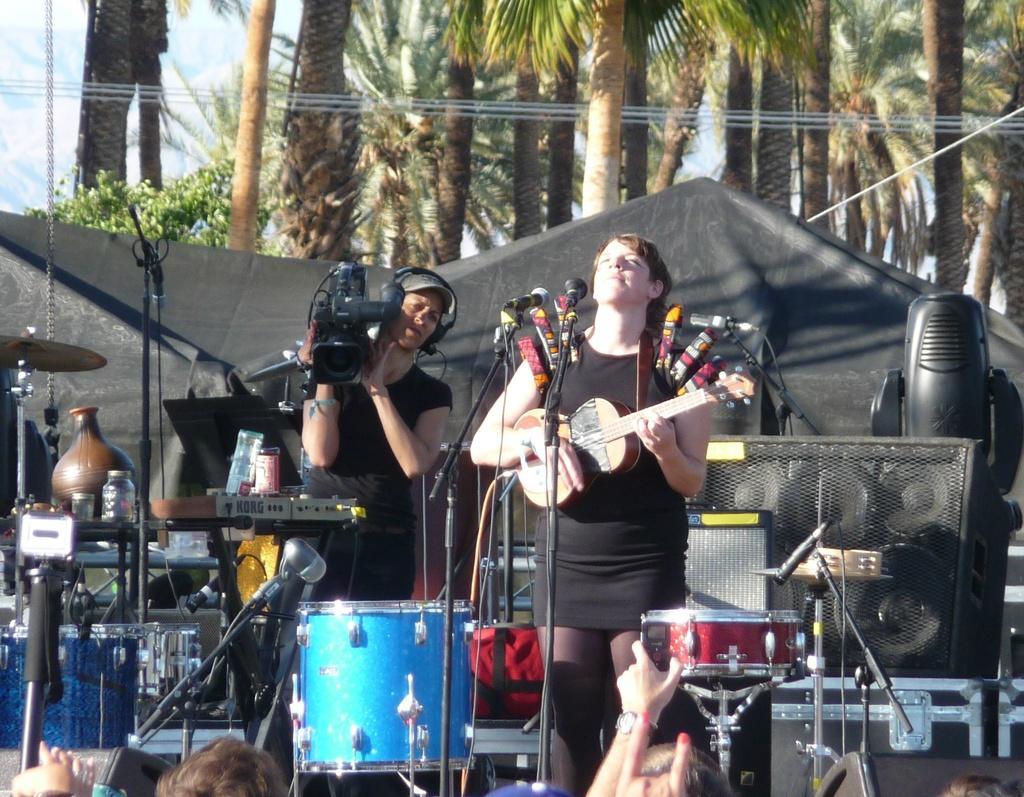Could you give a brief overview of what you see in this image? In this image I can see two person. The woman is holding a guitar. At the back side the woman is holding a camera. There are some musical instrument. At the back side there is a trees. 